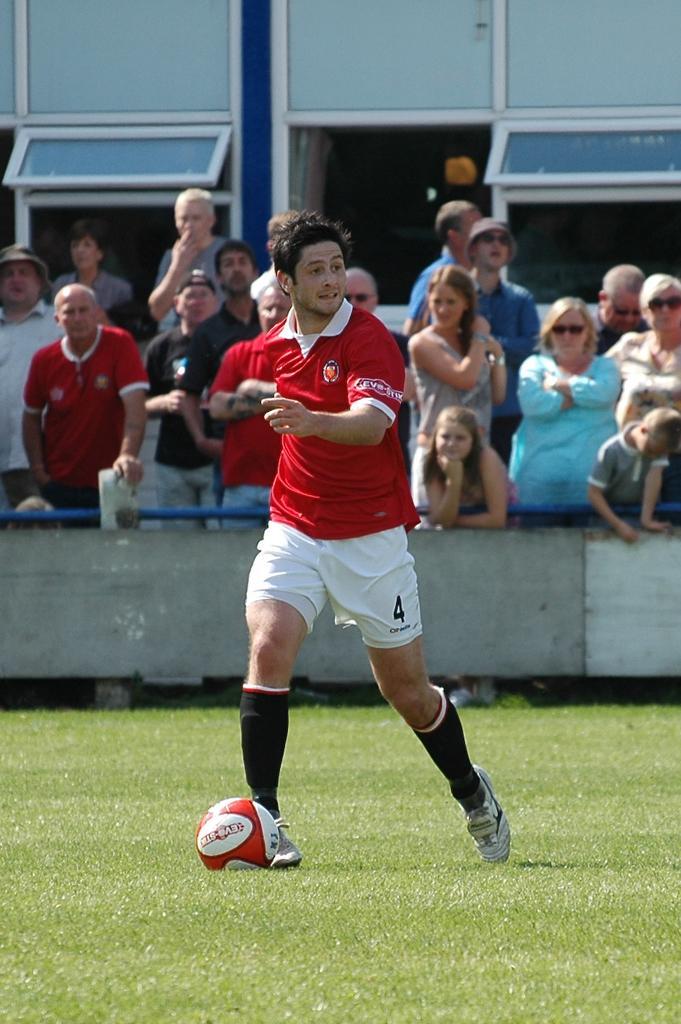Could you give a brief overview of what you see in this image? In this picture we can see a person who is a sports player wearing red color shirt and white shorts is on the pitch and behind him there are people standing and watching him. 